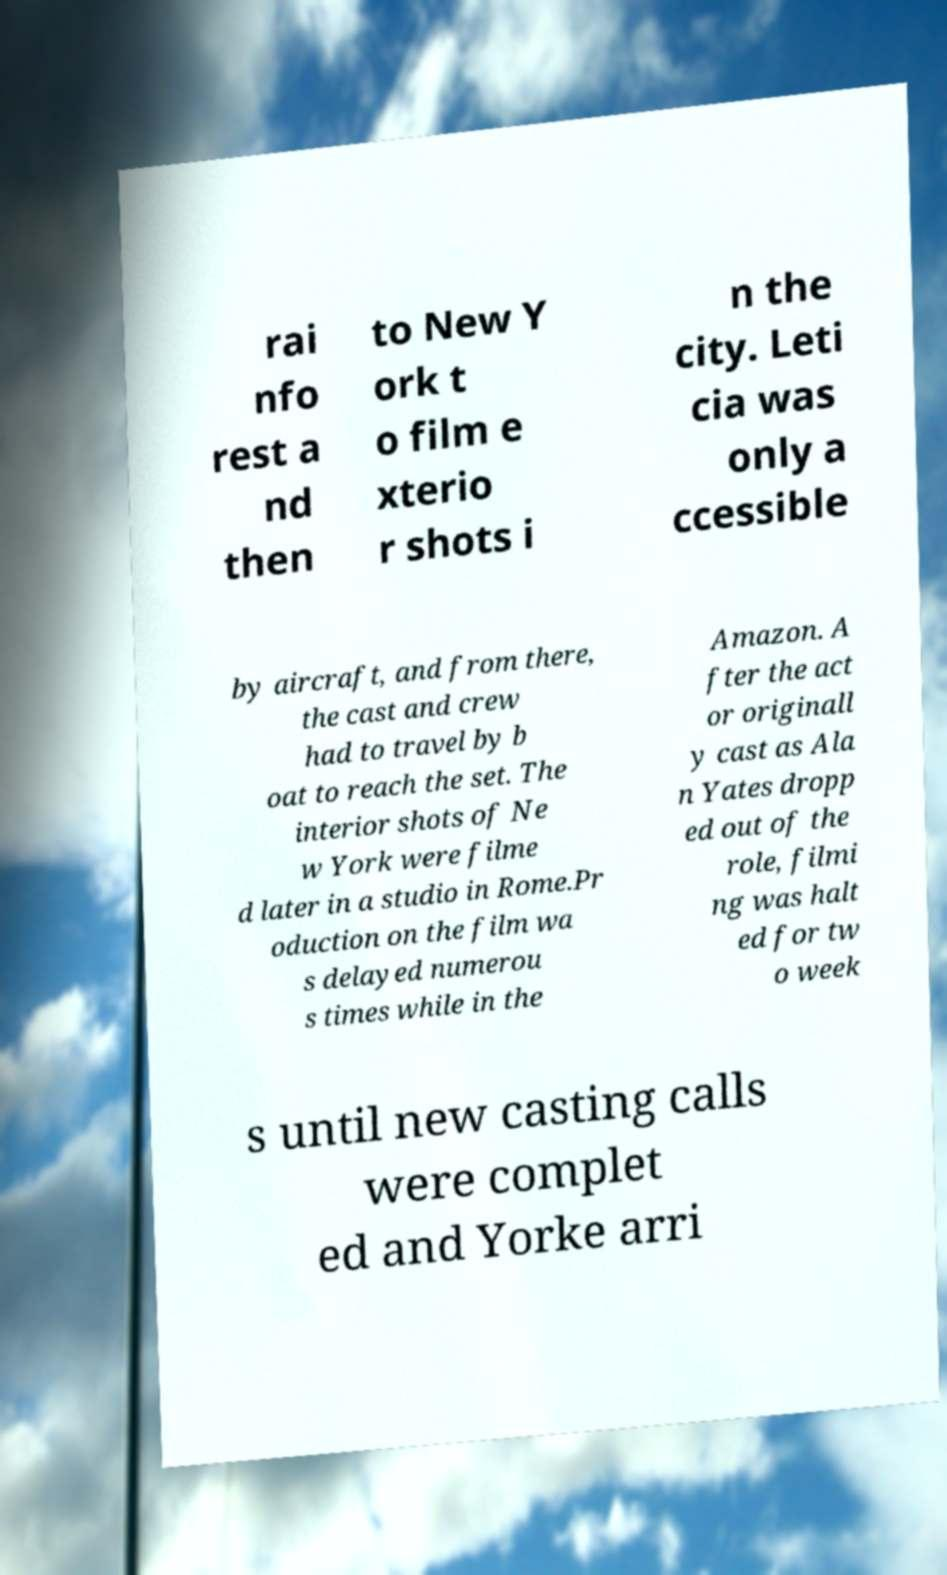Please identify and transcribe the text found in this image. rai nfo rest a nd then to New Y ork t o film e xterio r shots i n the city. Leti cia was only a ccessible by aircraft, and from there, the cast and crew had to travel by b oat to reach the set. The interior shots of Ne w York were filme d later in a studio in Rome.Pr oduction on the film wa s delayed numerou s times while in the Amazon. A fter the act or originall y cast as Ala n Yates dropp ed out of the role, filmi ng was halt ed for tw o week s until new casting calls were complet ed and Yorke arri 